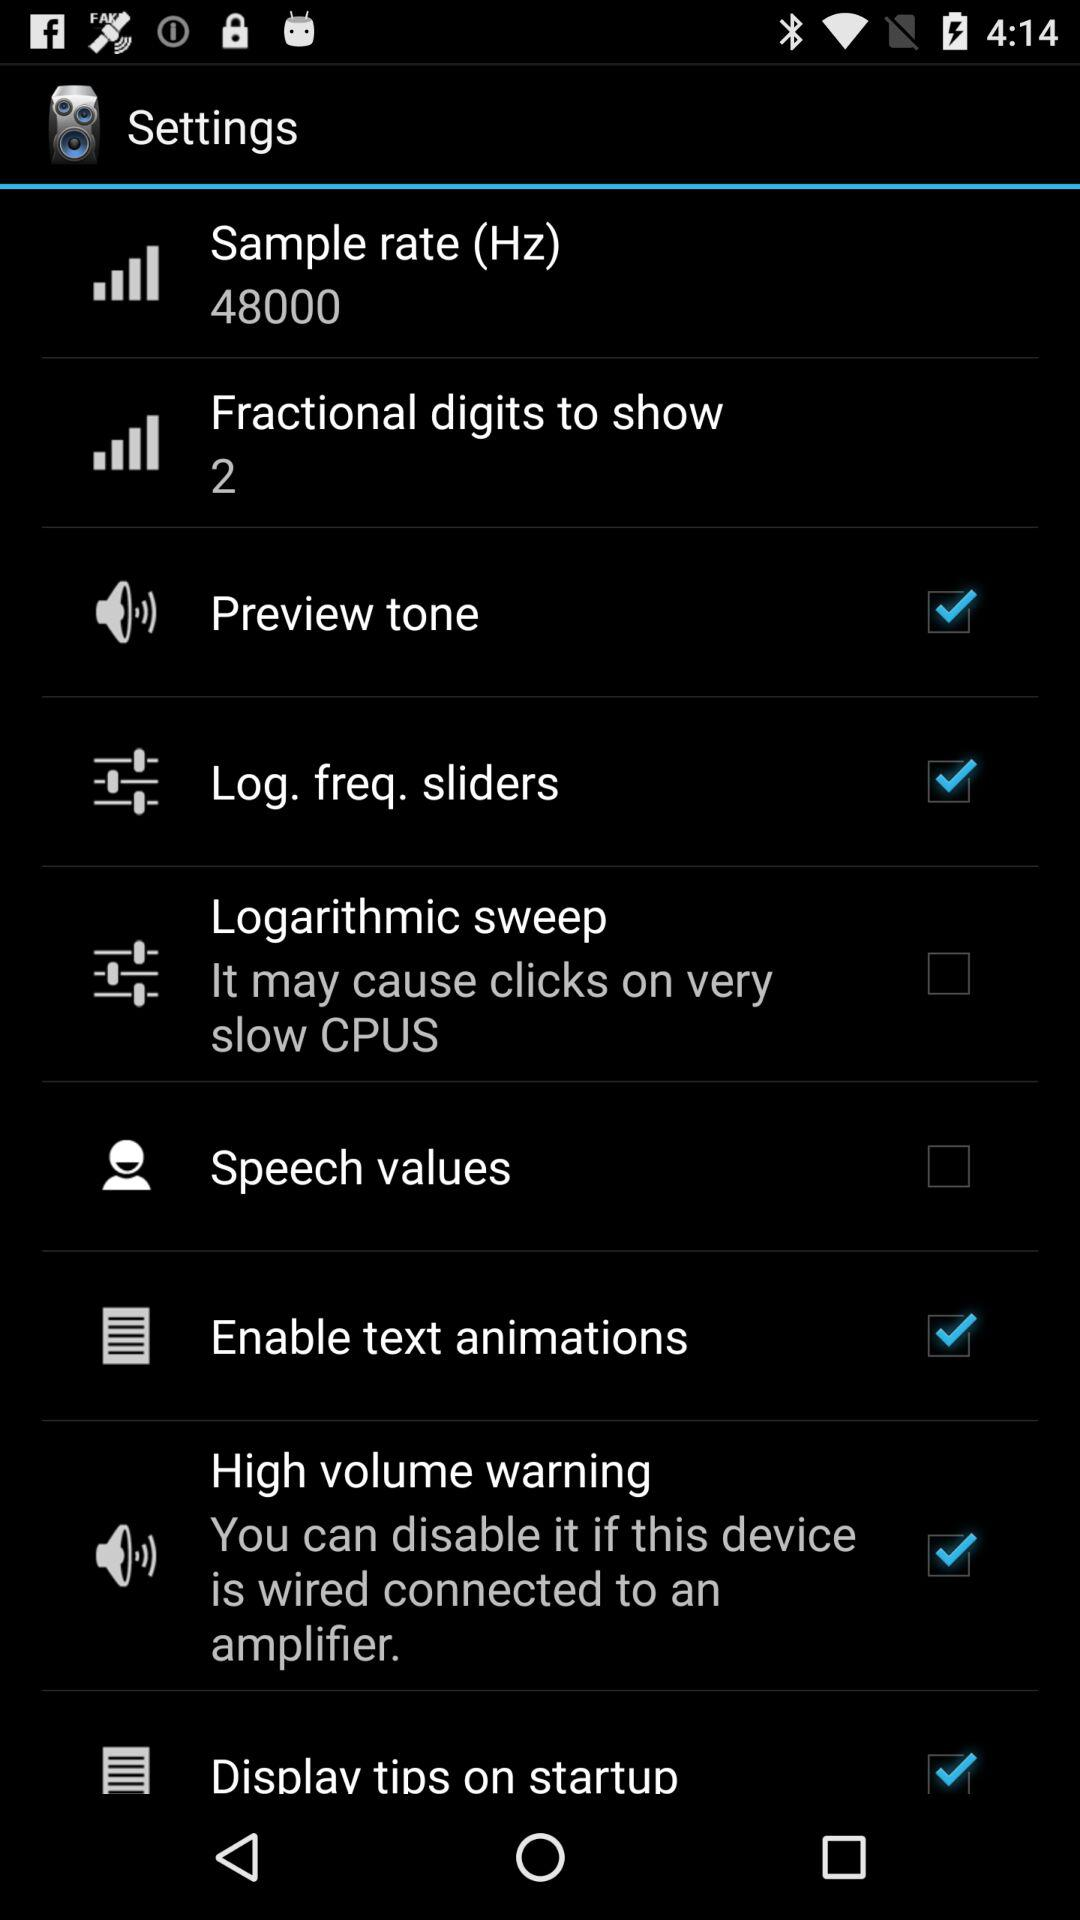How many fractional digits are there to show? There are 2 fractional digits to show. 